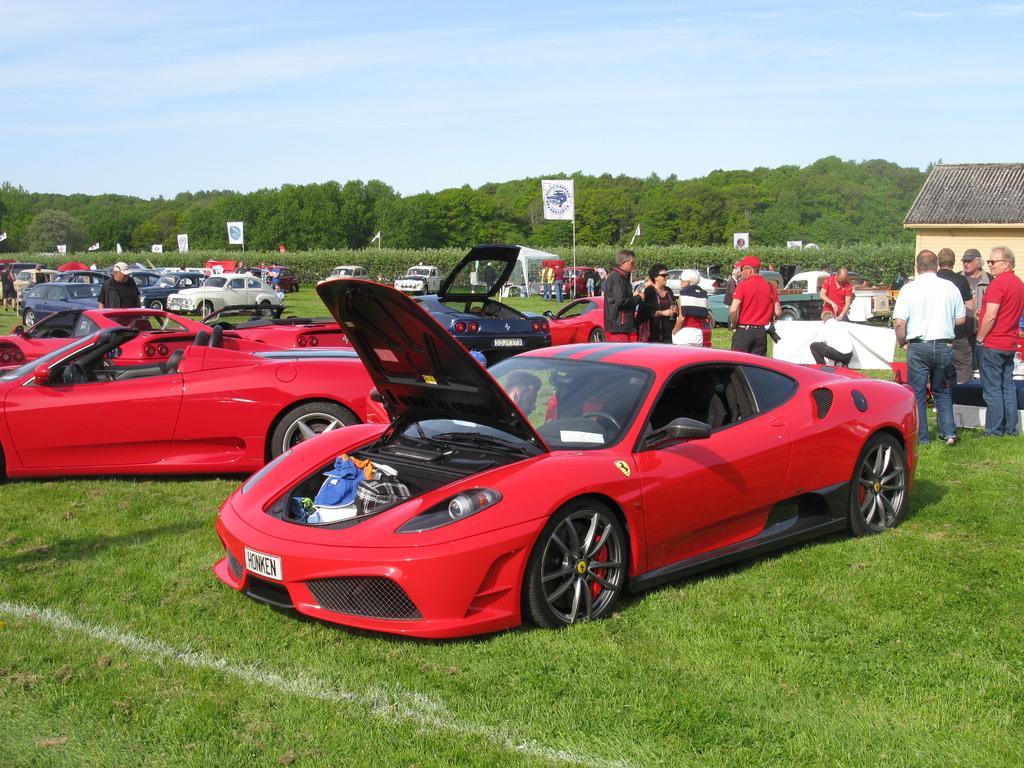Please provide a concise description of this image. In this image we can see some vehicles and there are some people and we can see a house on the right side of the image. We can see some flags and there are some plants, trees and grass on the ground and at the top we can see the sky. 